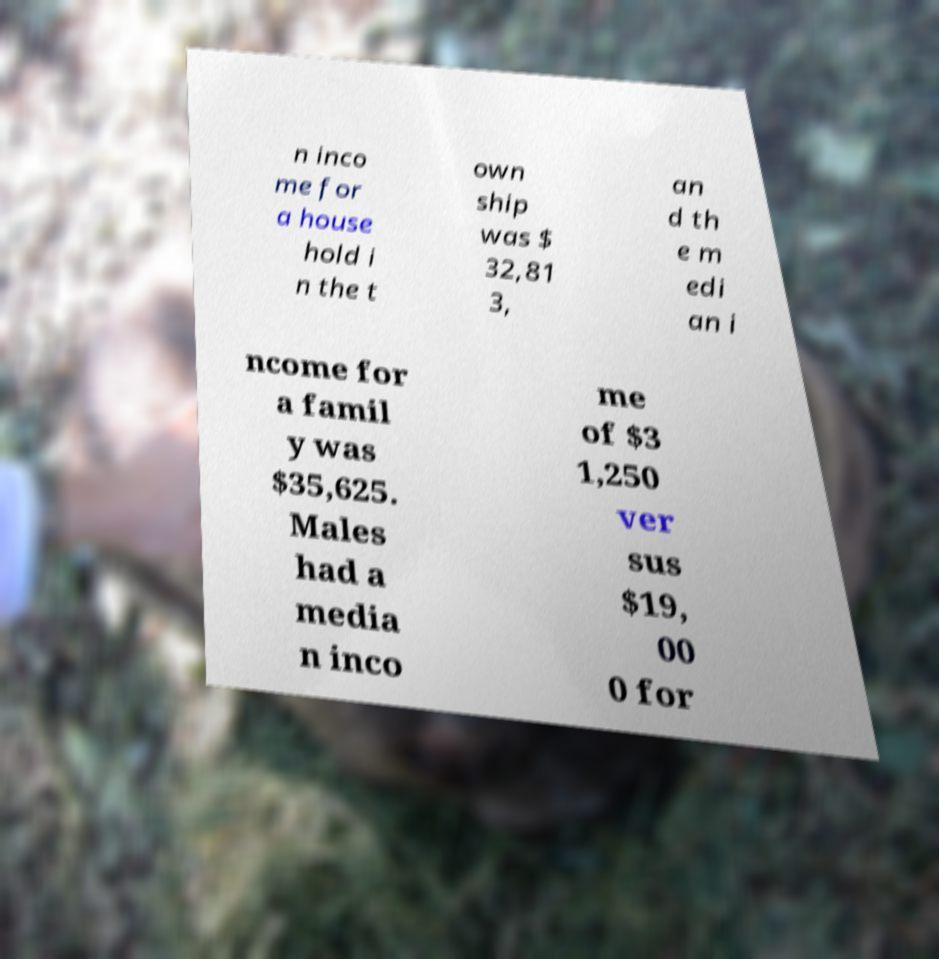For documentation purposes, I need the text within this image transcribed. Could you provide that? n inco me for a house hold i n the t own ship was $ 32,81 3, an d th e m edi an i ncome for a famil y was $35,625. Males had a media n inco me of $3 1,250 ver sus $19, 00 0 for 